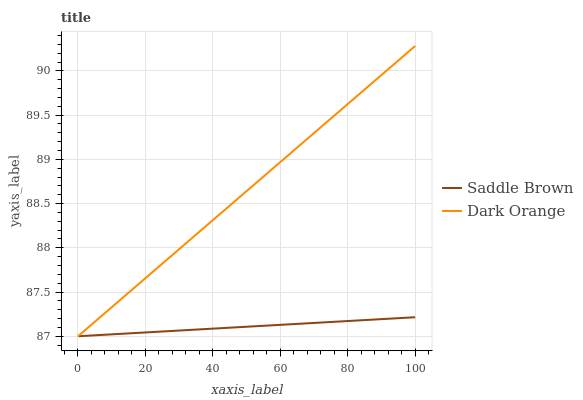Does Saddle Brown have the minimum area under the curve?
Answer yes or no. Yes. Does Dark Orange have the maximum area under the curve?
Answer yes or no. Yes. Does Saddle Brown have the maximum area under the curve?
Answer yes or no. No. Is Saddle Brown the smoothest?
Answer yes or no. Yes. Is Dark Orange the roughest?
Answer yes or no. Yes. Is Saddle Brown the roughest?
Answer yes or no. No. Does Dark Orange have the lowest value?
Answer yes or no. Yes. Does Dark Orange have the highest value?
Answer yes or no. Yes. Does Saddle Brown have the highest value?
Answer yes or no. No. Does Saddle Brown intersect Dark Orange?
Answer yes or no. Yes. Is Saddle Brown less than Dark Orange?
Answer yes or no. No. Is Saddle Brown greater than Dark Orange?
Answer yes or no. No. 